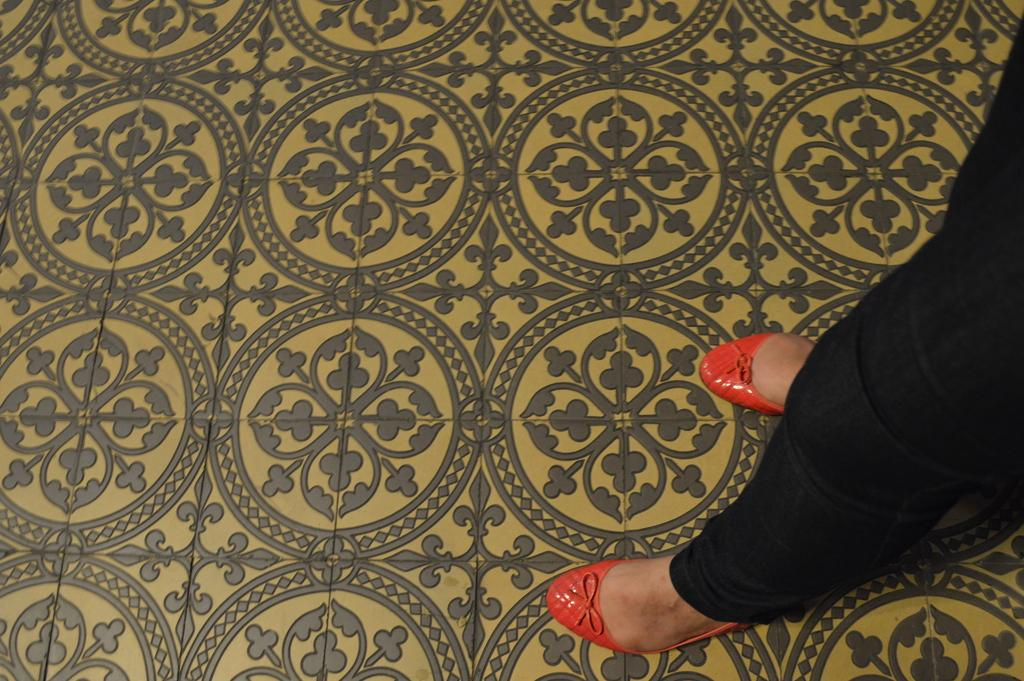What can be seen in the image related to a person? There is a person in the image. What type of clothing is the person wearing on their lower body? The person is wearing black pants. What type of footwear is the person wearing? The person is wearing red shoes. Where is the person standing in the image? The person is standing on the floor. Can you describe the floor in the image? The floor has a different design. What type of tree can be seen in the image? There is no tree present in the image. What game is the person playing in the image? There is no game being played in the image. 